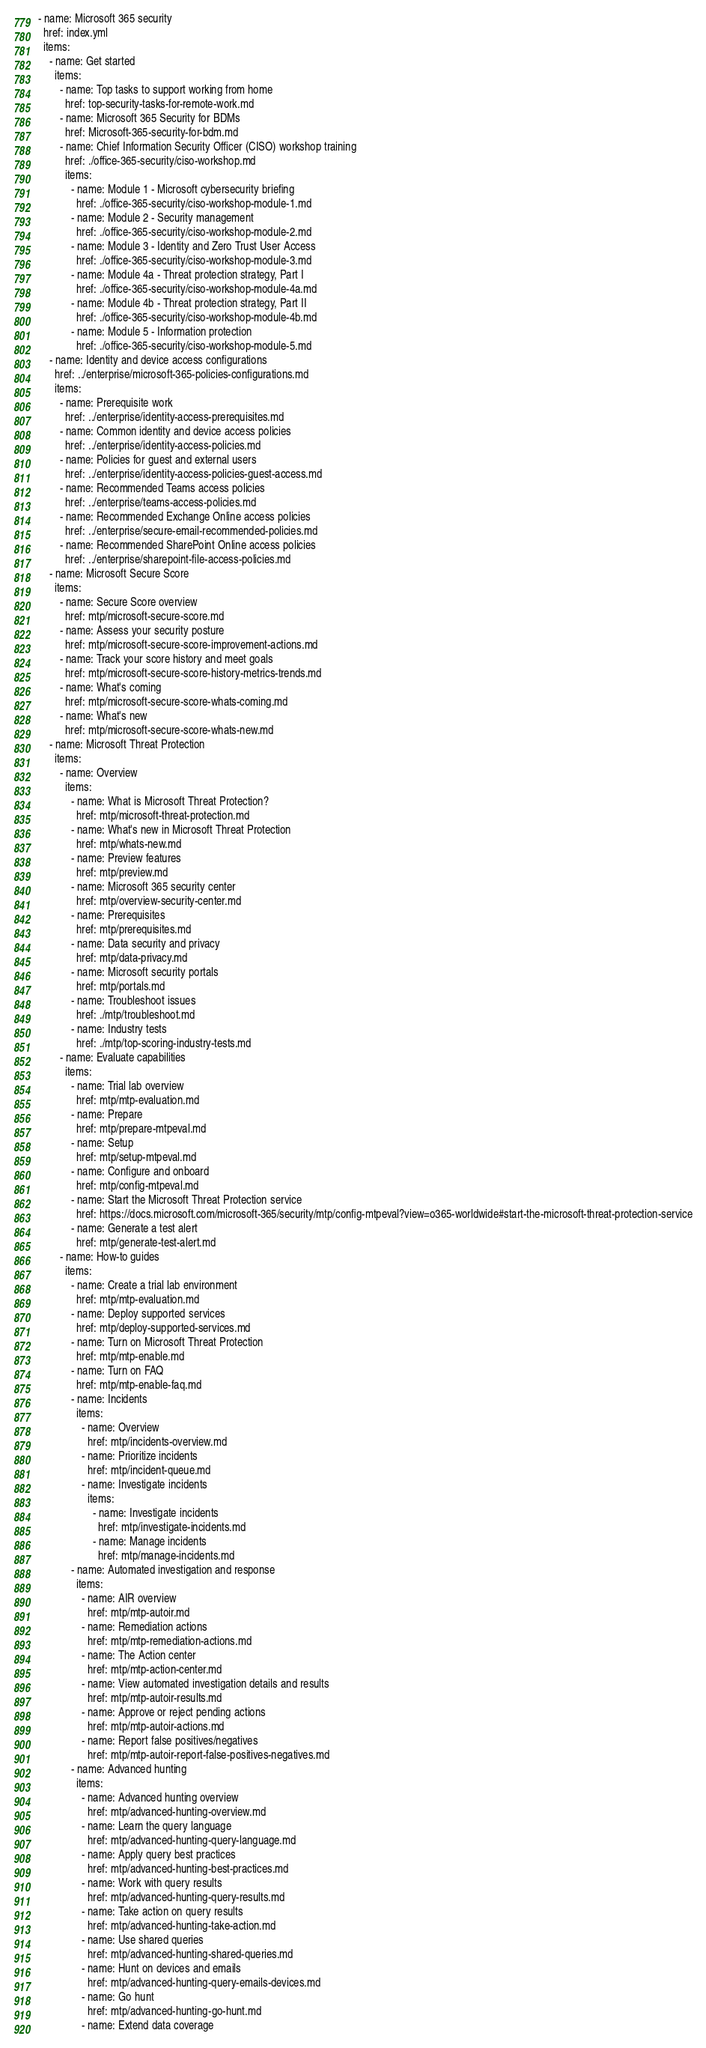Convert code to text. <code><loc_0><loc_0><loc_500><loc_500><_YAML_>- name: Microsoft 365 security
  href: index.yml
  items: 
    - name: Get started
      items: 
        - name: Top tasks to support working from home
          href: top-security-tasks-for-remote-work.md
        - name: Microsoft 365 Security for BDMs
          href: Microsoft-365-security-for-bdm.md
        - name: Chief Information Security Officer (CISO) workshop training
          href: ./office-365-security/ciso-workshop.md
          items: 
            - name: Module 1 - Microsoft cybersecurity briefing
              href: ./office-365-security/ciso-workshop-module-1.md
            - name: Module 2 - Security management
              href: ./office-365-security/ciso-workshop-module-2.md
            - name: Module 3 - Identity and Zero Trust User Access
              href: ./office-365-security/ciso-workshop-module-3.md
            - name: Module 4a - Threat protection strategy, Part I
              href: ./office-365-security/ciso-workshop-module-4a.md
            - name: Module 4b - Threat protection strategy, Part II
              href: ./office-365-security/ciso-workshop-module-4b.md
            - name: Module 5 - Information protection
              href: ./office-365-security/ciso-workshop-module-5.md
    - name: Identity and device access configurations
      href: ../enterprise/microsoft-365-policies-configurations.md
      items: 
        - name: Prerequisite work
          href: ../enterprise/identity-access-prerequisites.md
        - name: Common identity and device access policies
          href: ../enterprise/identity-access-policies.md
        - name: Policies for guest and external users
          href: ../enterprise/identity-access-policies-guest-access.md
        - name: Recommended Teams access policies
          href: ../enterprise/teams-access-policies.md
        - name: Recommended Exchange Online access policies
          href: ../enterprise/secure-email-recommended-policies.md
        - name: Recommended SharePoint Online access policies
          href: ../enterprise/sharepoint-file-access-policies.md
    - name: Microsoft Secure Score
      items: 
        - name: Secure Score overview
          href: mtp/microsoft-secure-score.md
        - name: Assess your security posture
          href: mtp/microsoft-secure-score-improvement-actions.md
        - name: Track your score history and meet goals
          href: mtp/microsoft-secure-score-history-metrics-trends.md
        - name: What's coming
          href: mtp/microsoft-secure-score-whats-coming.md
        - name: What's new
          href: mtp/microsoft-secure-score-whats-new.md
    - name: Microsoft Threat Protection
      items: 
        - name: Overview
          items: 
            - name: What is Microsoft Threat Protection?
              href: mtp/microsoft-threat-protection.md
            - name: What's new in Microsoft Threat Protection
              href: mtp/whats-new.md
            - name: Preview features
              href: mtp/preview.md
            - name: Microsoft 365 security center
              href: mtp/overview-security-center.md
            - name: Prerequisites
              href: mtp/prerequisites.md
            - name: Data security and privacy
              href: mtp/data-privacy.md
            - name: Microsoft security portals
              href: mtp/portals.md
            - name: Troubleshoot issues
              href: ./mtp/troubleshoot.md
            - name: Industry tests
              href: ./mtp/top-scoring-industry-tests.md 
        - name: Evaluate capabilities
          items: 
            - name: Trial lab overview
              href: mtp/mtp-evaluation.md
            - name: Prepare
              href: mtp/prepare-mtpeval.md
            - name: Setup
              href: mtp/setup-mtpeval.md
            - name: Configure and onboard
              href: mtp/config-mtpeval.md
            - name: Start the Microsoft Threat Protection service
              href: https://docs.microsoft.com/microsoft-365/security/mtp/config-mtpeval?view=o365-worldwide#start-the-microsoft-threat-protection-service
            - name: Generate a test alert
              href: mtp/generate-test-alert.md
        - name: How-to guides
          items: 
            - name: Create a trial lab environment
              href: mtp/mtp-evaluation.md             
            - name: Deploy supported services
              href: mtp/deploy-supported-services.md
            - name: Turn on Microsoft Threat Protection
              href: mtp/mtp-enable.md
            - name: Turn on FAQ
              href: mtp/mtp-enable-faq.md
            - name: Incidents
              items: 
                - name: Overview
                  href: mtp/incidents-overview.md
                - name: Prioritize incidents
                  href: mtp/incident-queue.md
                - name: Investigate incidents
                  items: 
                    - name: Investigate incidents
                      href: mtp/investigate-incidents.md
                    - name: Manage incidents
                      href: mtp/manage-incidents.md
            - name: Automated investigation and response
              items: 
                - name: AIR overview
                  href: mtp/mtp-autoir.md
                - name: Remediation actions
                  href: mtp/mtp-remediation-actions.md
                - name: The Action center
                  href: mtp/mtp-action-center.md
                - name: View automated investigation details and results
                  href: mtp/mtp-autoir-results.md
                - name: Approve or reject pending actions
                  href: mtp/mtp-autoir-actions.md
                - name: Report false positives/negatives
                  href: mtp/mtp-autoir-report-false-positives-negatives.md
            - name: Advanced hunting
              items: 
                - name: Advanced hunting overview
                  href: mtp/advanced-hunting-overview.md
                - name: Learn the query language
                  href: mtp/advanced-hunting-query-language.md
                - name: Apply query best practices
                  href: mtp/advanced-hunting-best-practices.md
                - name: Work with query results
                  href: mtp/advanced-hunting-query-results.md
                - name: Take action on query results
                  href: mtp/advanced-hunting-take-action.md
                - name: Use shared queries
                  href: mtp/advanced-hunting-shared-queries.md
                - name: Hunt on devices and emails
                  href: mtp/advanced-hunting-query-emails-devices.md
                - name: Go hunt
                  href: mtp/advanced-hunting-go-hunt.md
                - name: Extend data coverage</code> 